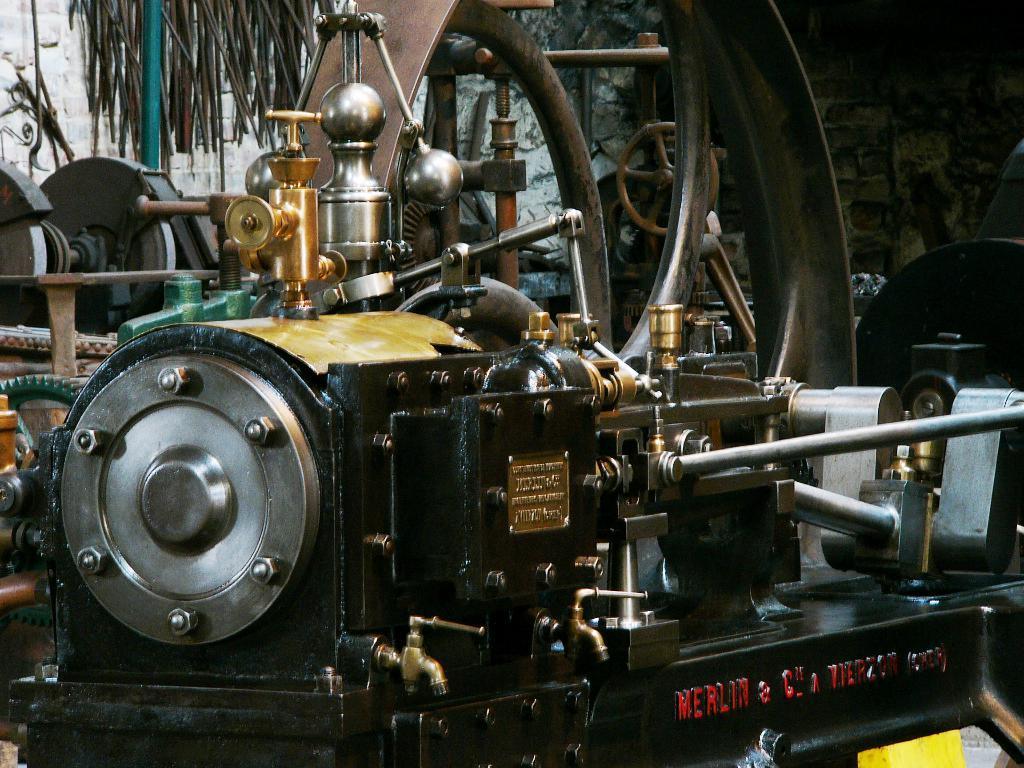Could you give a brief overview of what you see in this image? In this image I can see a engine of vehicle and at the top I can see the wall. 